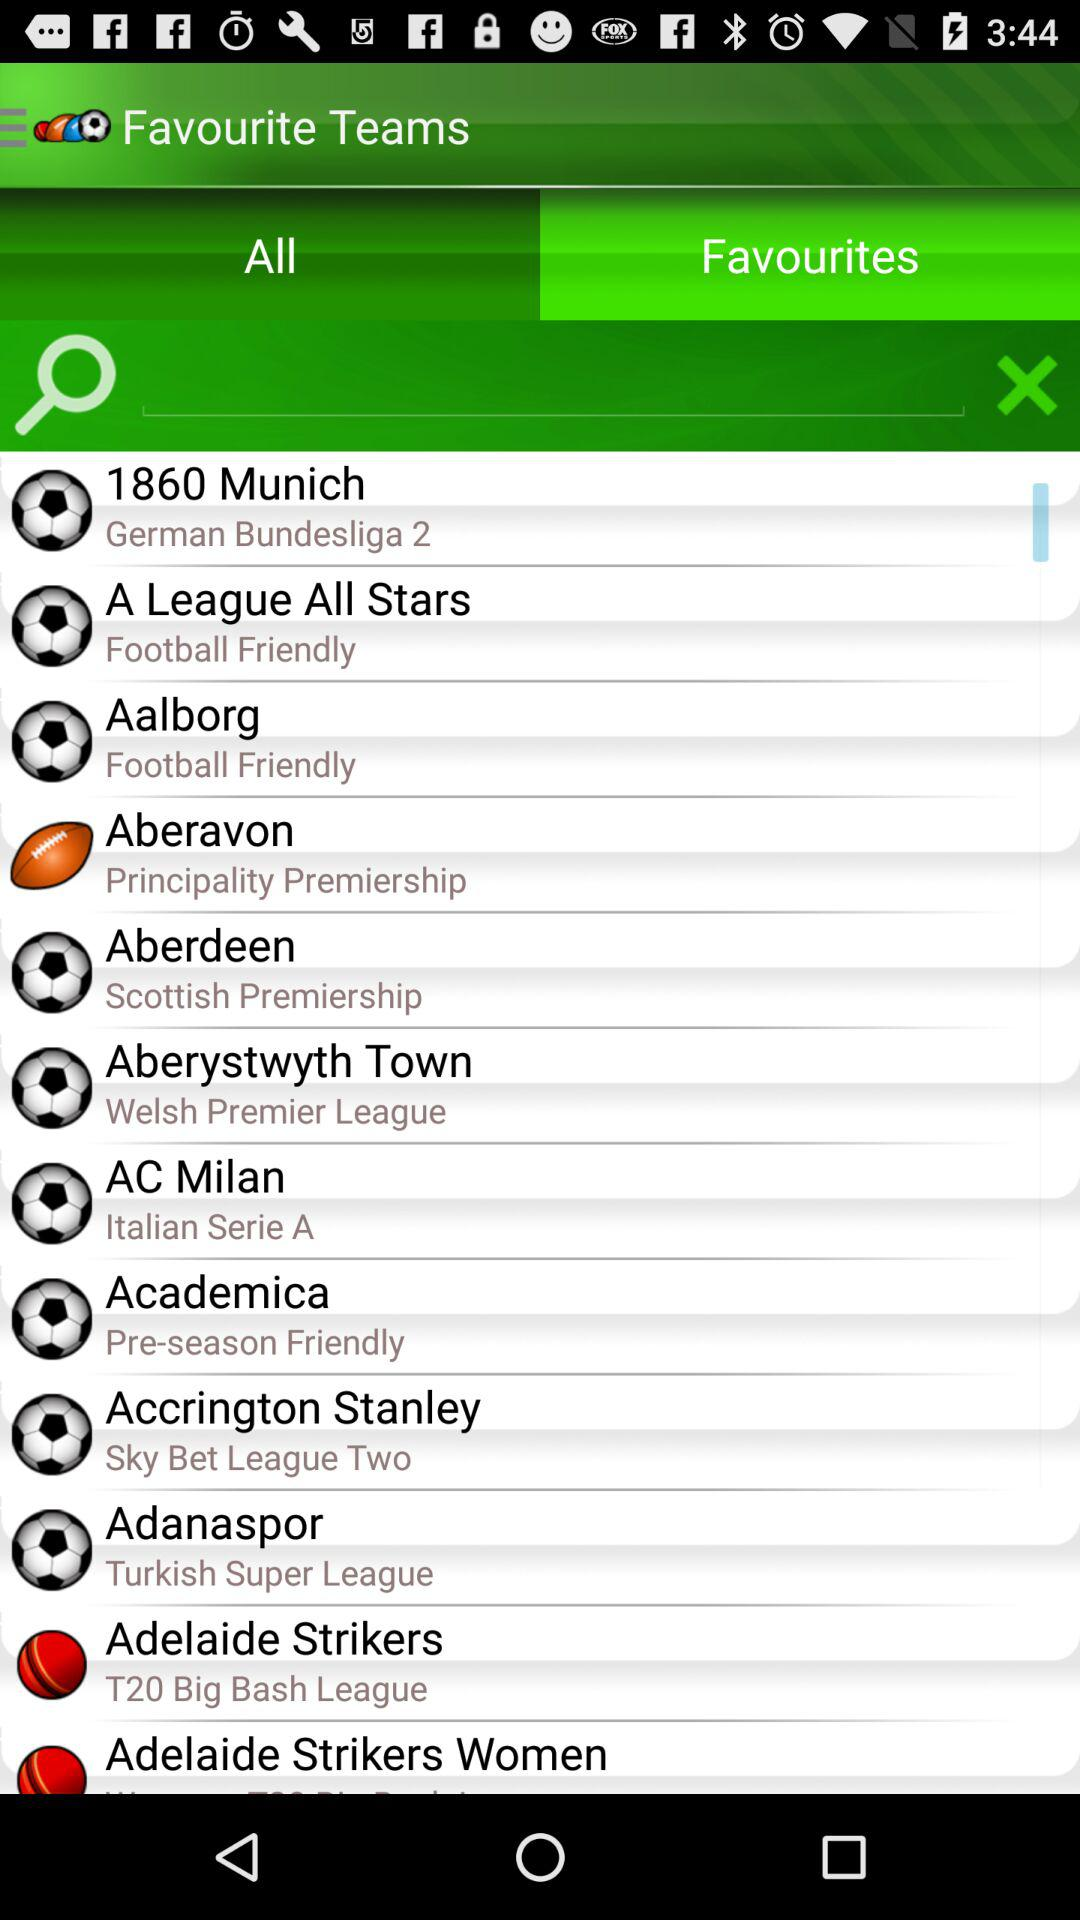In which league will "AC Milan" play? "AC Milan" will play in "Italian Serie A". 